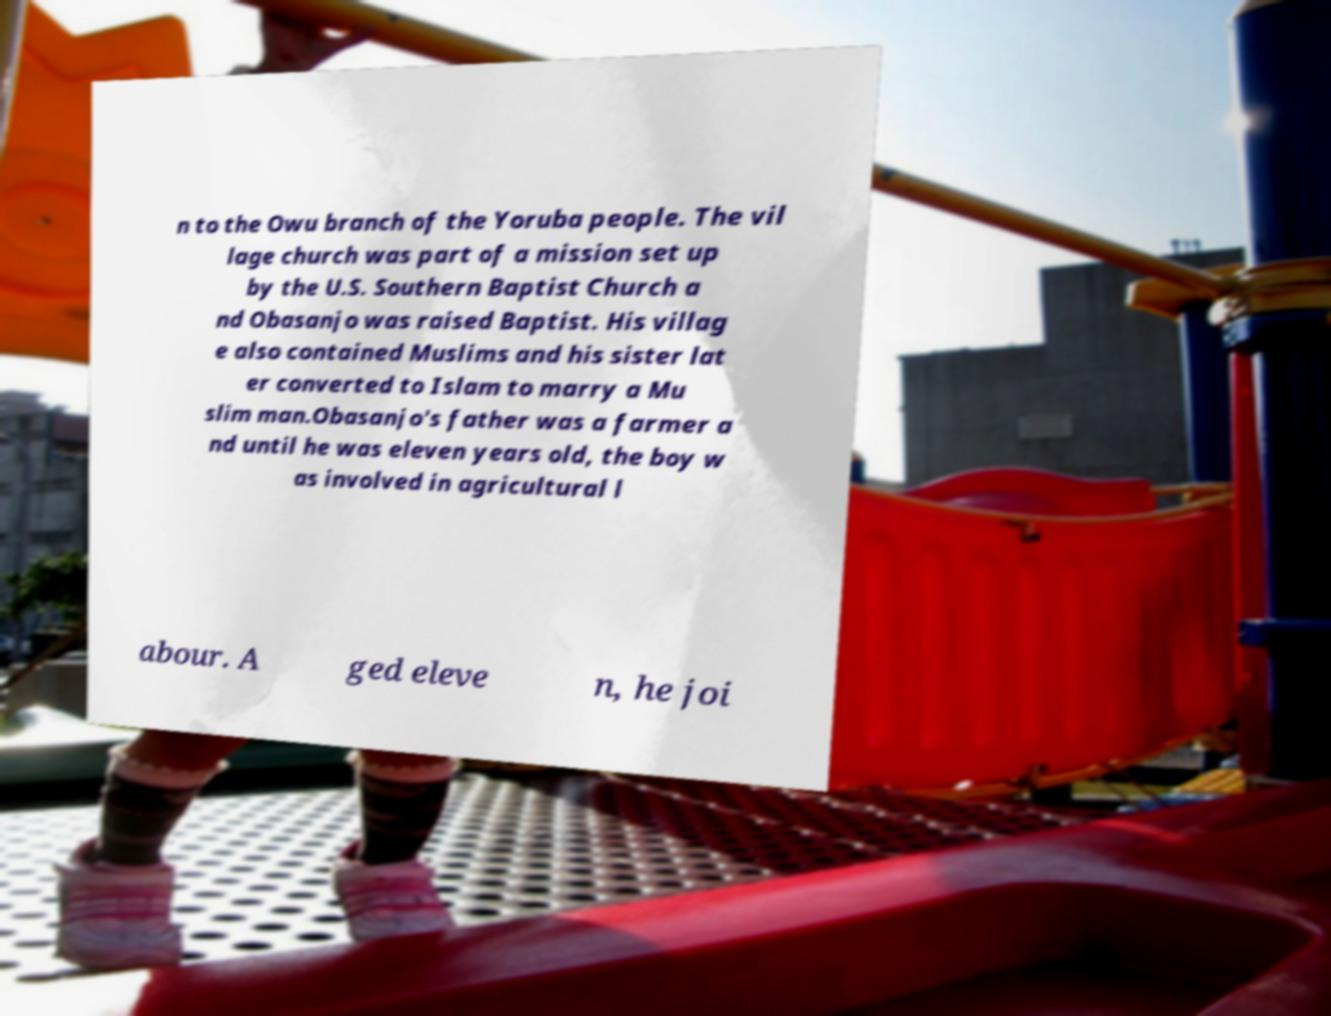Can you accurately transcribe the text from the provided image for me? n to the Owu branch of the Yoruba people. The vil lage church was part of a mission set up by the U.S. Southern Baptist Church a nd Obasanjo was raised Baptist. His villag e also contained Muslims and his sister lat er converted to Islam to marry a Mu slim man.Obasanjo's father was a farmer a nd until he was eleven years old, the boy w as involved in agricultural l abour. A ged eleve n, he joi 